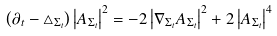<formula> <loc_0><loc_0><loc_500><loc_500>\left ( \partial _ { t } - \triangle _ { \Sigma _ { t } } \right ) \left | A _ { \Sigma _ { t } } \right | ^ { 2 } = - 2 \left | \nabla _ { \Sigma _ { t } } A _ { \Sigma _ { t } } \right | ^ { 2 } + 2 \left | A _ { \Sigma _ { t } } \right | ^ { 4 }</formula> 